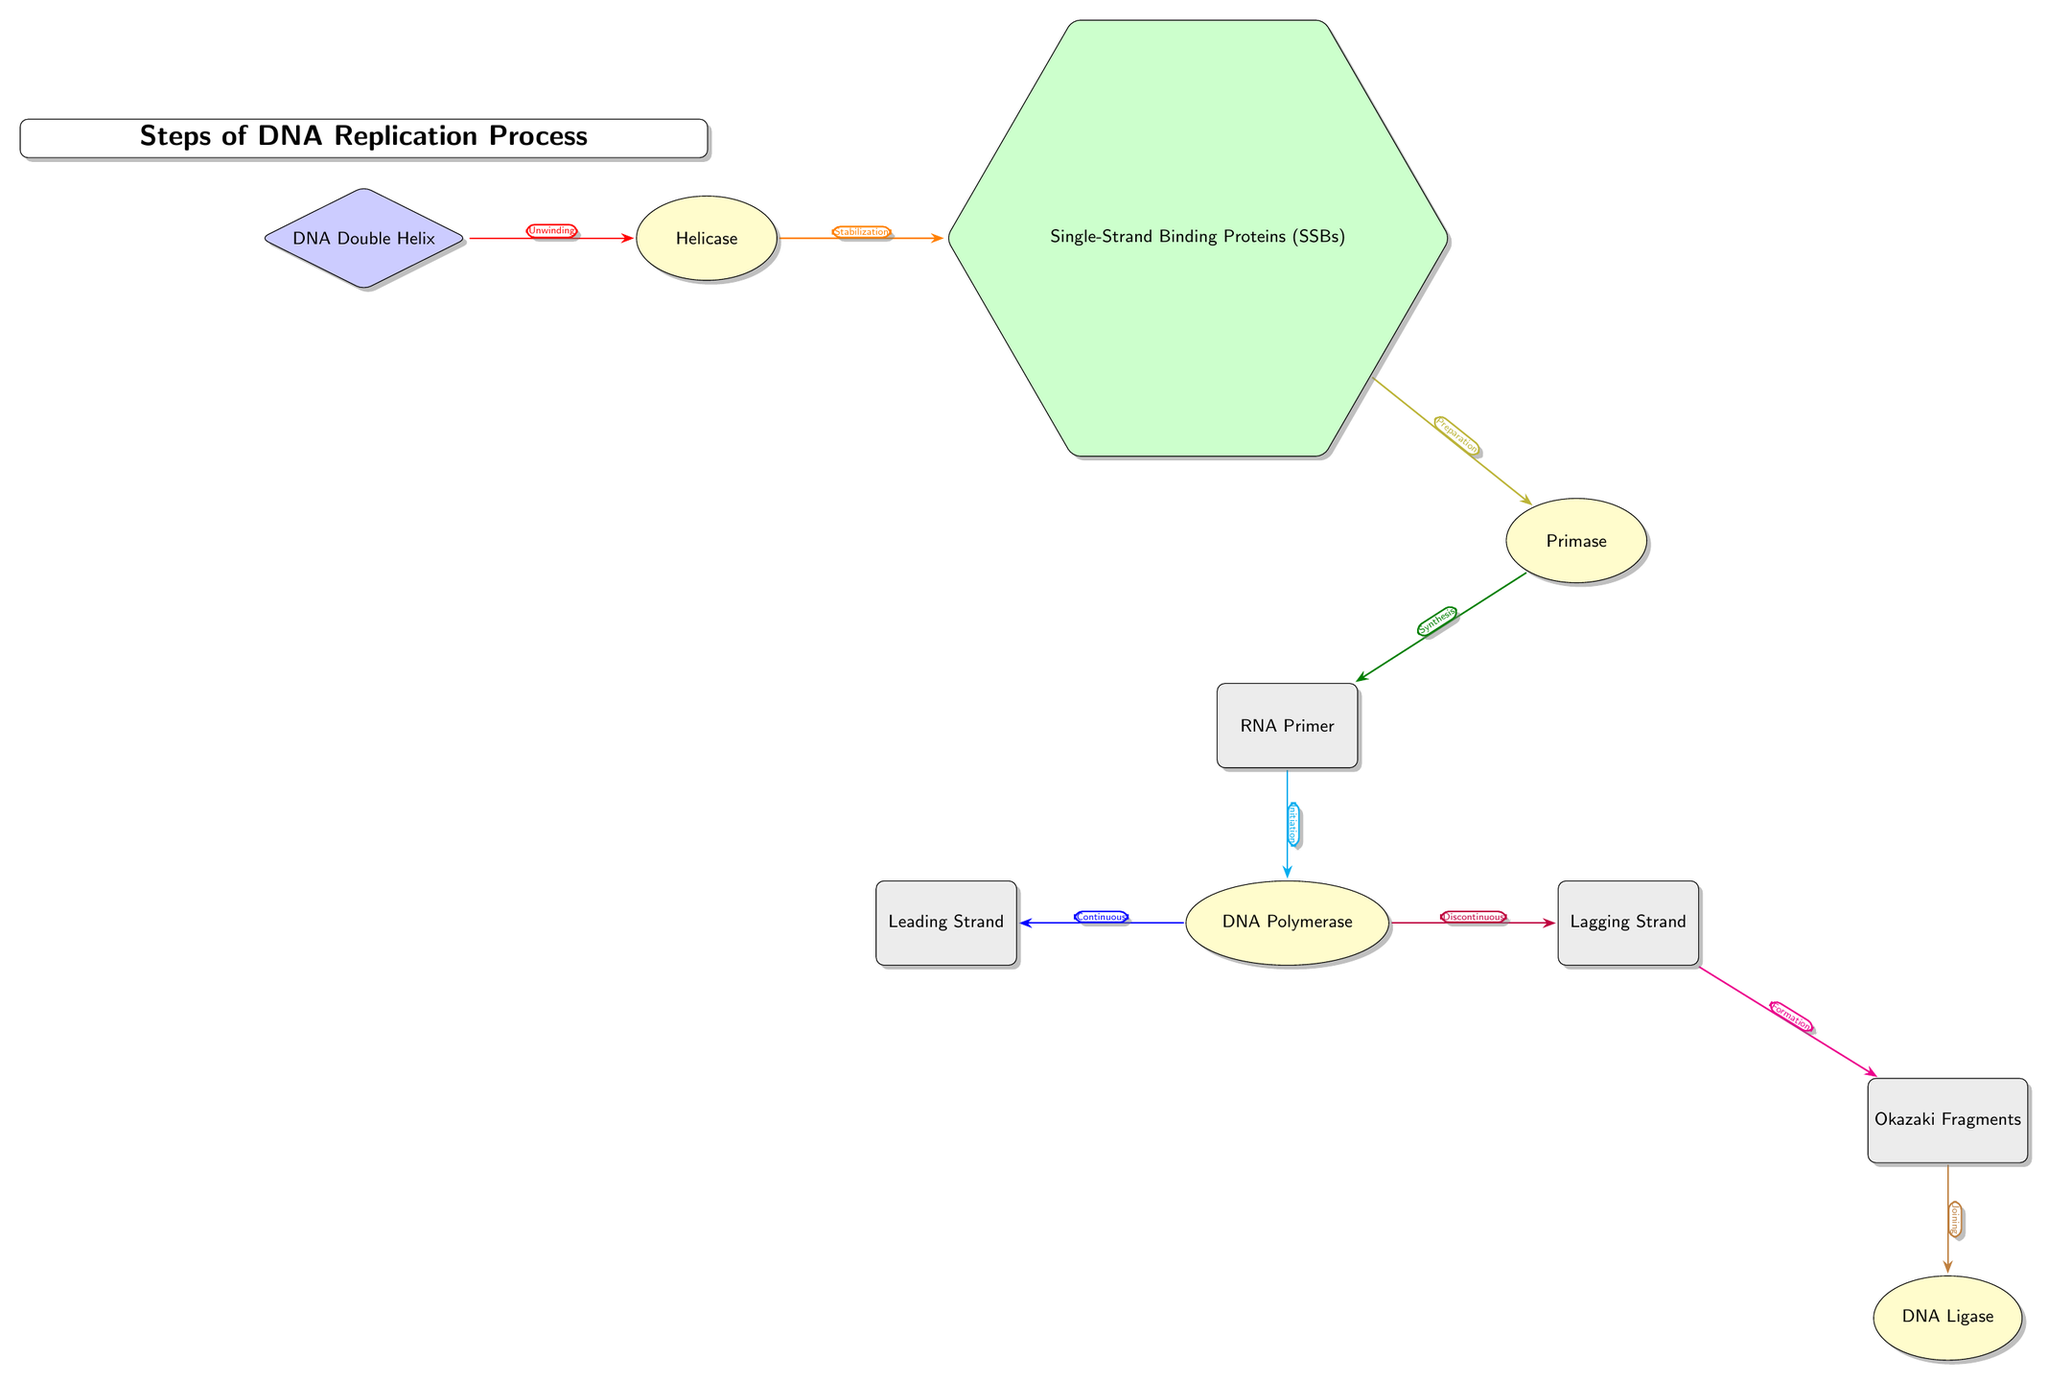What is the first step in DNA replication? The first step is represented by the arrow from the DNA Double Helix to Helicase, indicating "Unwinding." This is where the DNA double helix is separated into two strands.
Answer: Unwinding Which protein stabilizes the DNA strands during replication? The diagram shows an arrow leading from Helicase to Single-Strand Binding Proteins, labeled "Stabilization." This means that Single-Strand Binding Proteins are responsible for stabilizing the unwound DNA strands.
Answer: Single-Strand Binding Proteins (SSBs) How many main enzymes are involved in the DNA replication process? In the diagram, there are three enzymes indicated: Helicase, Primase, and DNA Ligase. By counting the enzyme nodes, we find that there are a total of three enzymes involved.
Answer: 3 What type of strand is produced continuously during replication? The arrow from Polymerase to Leading Strand indicates that DNA Polymerase synthesizes this strand continuously as replication progresses. It represents the direction of new DNA strand formation.
Answer: Leading Strand How do Okazaki Fragments relate to the lagging strand? The diagram shows an arrow from Lagging Strand to Okazaki Fragments, labeled "Formation." This indicates that Okazaki Fragments are formed as part of the synthesis of the lagging strand during DNA replication.
Answer: Formation What happens after the Okazaki Fragments are formed? The diagram indicates with an arrow pointing from Okazaki Fragments to Ligase, labeled "Joining," which shows that after the formation of Okazaki Fragments, they are joined together by DNA Ligase.
Answer: Joining Which enzyme is responsible for synthesizing the RNA primer? The diagram has a clear connection from Primase to RNA Primer, labeled "Synthesis." This indicates that Primase synthesizes the RNA primer needed for DNA replication initiation.
Answer: Primase What is the function of DNA Polymerase during replication? According to the diagram, DNA Polymerase has connections to both the Leading Strand and Lagging Strand, labeled "Continuous" and "Discontinuous," respectively, indicating its role in synthesizing both strands of DNA at different rates.
Answer: Continuous and Discontinuous 